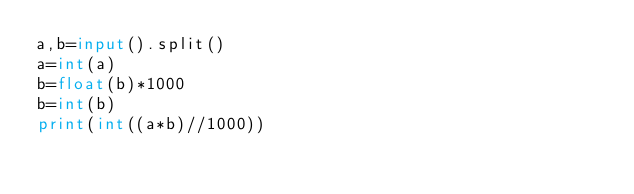Convert code to text. <code><loc_0><loc_0><loc_500><loc_500><_Python_>a,b=input().split()
a=int(a)
b=float(b)*1000
b=int(b)
print(int((a*b)//1000))</code> 